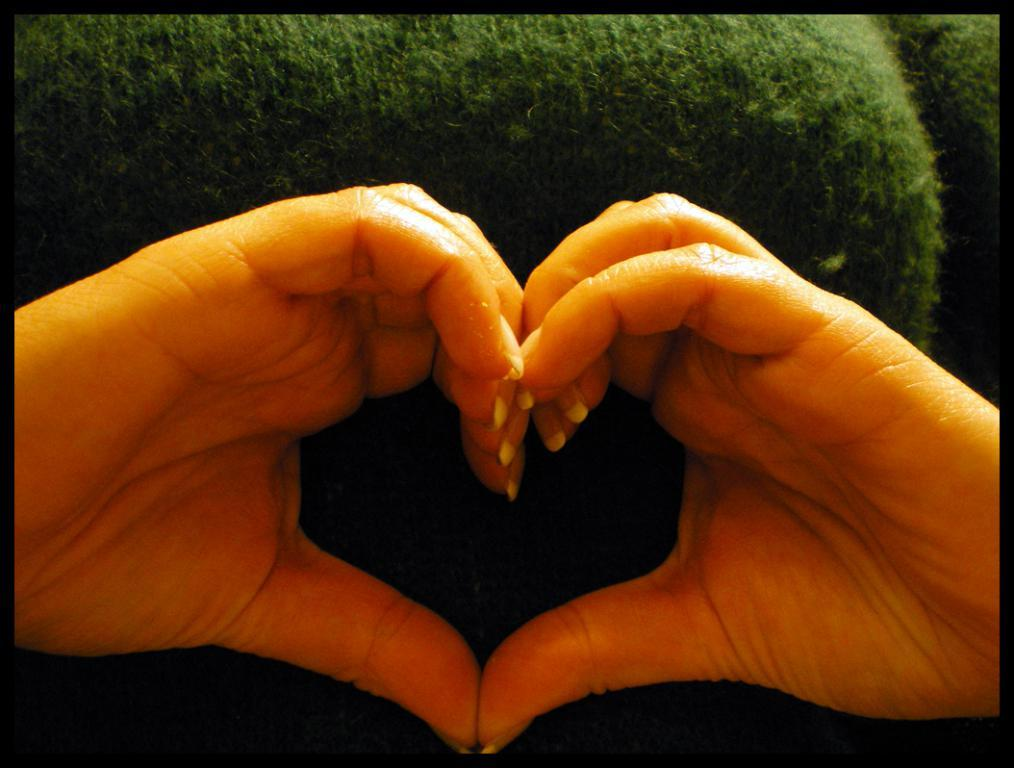What part of a person's body is visible in the image? There is a person's hands visible in the image. What color is the background of the image? The background of the image is green. What type of harmony is being played by the person in the image? There is no indication of any musical instrument or harmony in the image; only a person's hands are visible. What class of people might be associated with the person in the image? There is no information about the person's social class or any other people in the image. What type of attraction is present in the image? There is no attraction or any indication of a tourist spot in the image; it only shows a person's hands and a green background. 